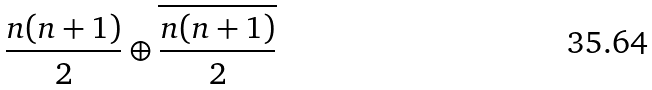<formula> <loc_0><loc_0><loc_500><loc_500>\frac { n ( n + 1 ) } { 2 } \oplus \overline { \frac { n ( n + 1 ) } { 2 } }</formula> 